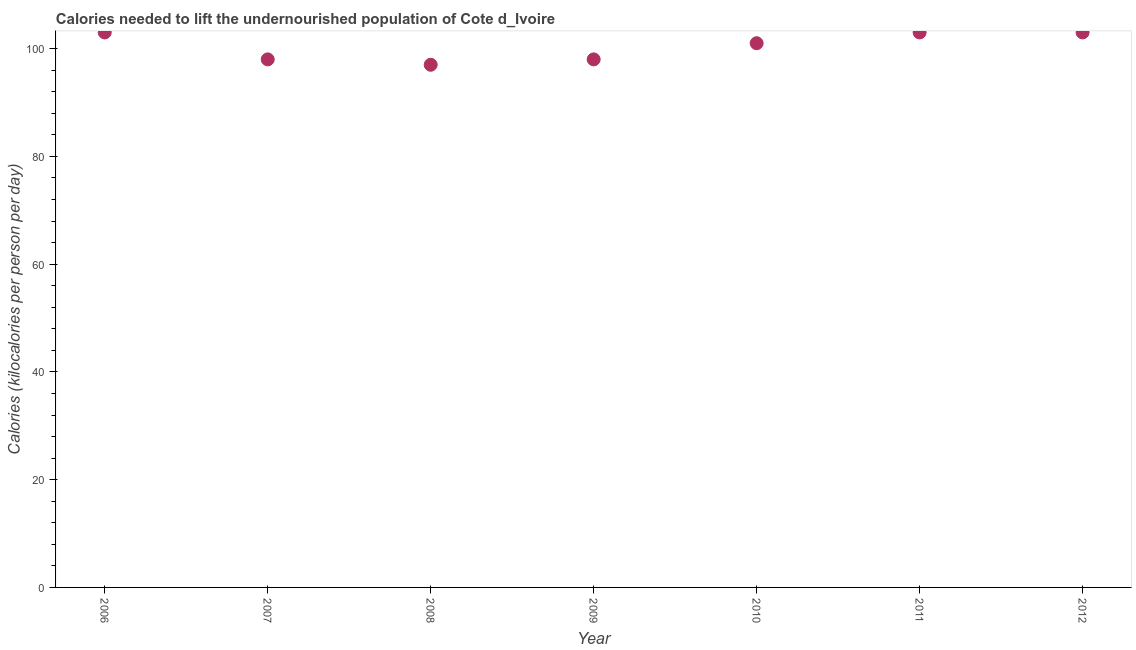What is the depth of food deficit in 2011?
Provide a short and direct response. 103. Across all years, what is the maximum depth of food deficit?
Your response must be concise. 103. Across all years, what is the minimum depth of food deficit?
Provide a short and direct response. 97. In which year was the depth of food deficit minimum?
Offer a terse response. 2008. What is the sum of the depth of food deficit?
Keep it short and to the point. 703. What is the difference between the depth of food deficit in 2009 and 2012?
Offer a terse response. -5. What is the average depth of food deficit per year?
Offer a terse response. 100.43. What is the median depth of food deficit?
Your answer should be very brief. 101. In how many years, is the depth of food deficit greater than 20 kilocalories?
Offer a very short reply. 7. What is the ratio of the depth of food deficit in 2007 to that in 2009?
Give a very brief answer. 1. Is the difference between the depth of food deficit in 2006 and 2009 greater than the difference between any two years?
Keep it short and to the point. No. What is the difference between the highest and the second highest depth of food deficit?
Your answer should be compact. 0. Is the sum of the depth of food deficit in 2008 and 2009 greater than the maximum depth of food deficit across all years?
Your answer should be very brief. Yes. How many dotlines are there?
Make the answer very short. 1. How many years are there in the graph?
Provide a short and direct response. 7. What is the difference between two consecutive major ticks on the Y-axis?
Provide a succinct answer. 20. Does the graph contain any zero values?
Provide a short and direct response. No. What is the title of the graph?
Ensure brevity in your answer.  Calories needed to lift the undernourished population of Cote d_Ivoire. What is the label or title of the X-axis?
Your answer should be very brief. Year. What is the label or title of the Y-axis?
Ensure brevity in your answer.  Calories (kilocalories per person per day). What is the Calories (kilocalories per person per day) in 2006?
Provide a succinct answer. 103. What is the Calories (kilocalories per person per day) in 2008?
Make the answer very short. 97. What is the Calories (kilocalories per person per day) in 2009?
Make the answer very short. 98. What is the Calories (kilocalories per person per day) in 2010?
Give a very brief answer. 101. What is the Calories (kilocalories per person per day) in 2011?
Your answer should be very brief. 103. What is the Calories (kilocalories per person per day) in 2012?
Make the answer very short. 103. What is the difference between the Calories (kilocalories per person per day) in 2006 and 2008?
Keep it short and to the point. 6. What is the difference between the Calories (kilocalories per person per day) in 2006 and 2009?
Ensure brevity in your answer.  5. What is the difference between the Calories (kilocalories per person per day) in 2006 and 2010?
Give a very brief answer. 2. What is the difference between the Calories (kilocalories per person per day) in 2006 and 2012?
Your answer should be compact. 0. What is the difference between the Calories (kilocalories per person per day) in 2007 and 2008?
Your answer should be compact. 1. What is the difference between the Calories (kilocalories per person per day) in 2007 and 2010?
Offer a very short reply. -3. What is the difference between the Calories (kilocalories per person per day) in 2007 and 2011?
Provide a short and direct response. -5. What is the difference between the Calories (kilocalories per person per day) in 2007 and 2012?
Provide a short and direct response. -5. What is the difference between the Calories (kilocalories per person per day) in 2008 and 2009?
Your answer should be very brief. -1. What is the difference between the Calories (kilocalories per person per day) in 2008 and 2010?
Provide a succinct answer. -4. What is the difference between the Calories (kilocalories per person per day) in 2008 and 2012?
Your answer should be compact. -6. What is the difference between the Calories (kilocalories per person per day) in 2009 and 2010?
Offer a very short reply. -3. What is the ratio of the Calories (kilocalories per person per day) in 2006 to that in 2007?
Your answer should be very brief. 1.05. What is the ratio of the Calories (kilocalories per person per day) in 2006 to that in 2008?
Your answer should be very brief. 1.06. What is the ratio of the Calories (kilocalories per person per day) in 2006 to that in 2009?
Provide a succinct answer. 1.05. What is the ratio of the Calories (kilocalories per person per day) in 2006 to that in 2011?
Provide a short and direct response. 1. What is the ratio of the Calories (kilocalories per person per day) in 2007 to that in 2008?
Keep it short and to the point. 1.01. What is the ratio of the Calories (kilocalories per person per day) in 2007 to that in 2010?
Your response must be concise. 0.97. What is the ratio of the Calories (kilocalories per person per day) in 2007 to that in 2011?
Offer a terse response. 0.95. What is the ratio of the Calories (kilocalories per person per day) in 2007 to that in 2012?
Your answer should be very brief. 0.95. What is the ratio of the Calories (kilocalories per person per day) in 2008 to that in 2011?
Your response must be concise. 0.94. What is the ratio of the Calories (kilocalories per person per day) in 2008 to that in 2012?
Make the answer very short. 0.94. What is the ratio of the Calories (kilocalories per person per day) in 2009 to that in 2010?
Make the answer very short. 0.97. What is the ratio of the Calories (kilocalories per person per day) in 2009 to that in 2011?
Keep it short and to the point. 0.95. What is the ratio of the Calories (kilocalories per person per day) in 2009 to that in 2012?
Your answer should be compact. 0.95. What is the ratio of the Calories (kilocalories per person per day) in 2010 to that in 2012?
Make the answer very short. 0.98. 